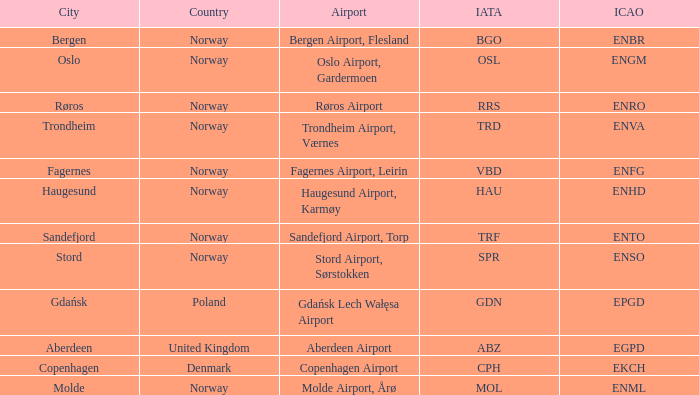Can you parse all the data within this table? {'header': ['City', 'Country', 'Airport', 'IATA', 'ICAO'], 'rows': [['Bergen', 'Norway', 'Bergen Airport, Flesland', 'BGO', 'ENBR'], ['Oslo', 'Norway', 'Oslo Airport, Gardermoen', 'OSL', 'ENGM'], ['Røros', 'Norway', 'Røros Airport', 'RRS', 'ENRO'], ['Trondheim', 'Norway', 'Trondheim Airport, Værnes', 'TRD', 'ENVA'], ['Fagernes', 'Norway', 'Fagernes Airport, Leirin', 'VBD', 'ENFG'], ['Haugesund', 'Norway', 'Haugesund Airport, Karmøy', 'HAU', 'ENHD'], ['Sandefjord', 'Norway', 'Sandefjord Airport, Torp', 'TRF', 'ENTO'], ['Stord', 'Norway', 'Stord Airport, Sørstokken', 'SPR', 'ENSO'], ['Gdańsk', 'Poland', 'Gdańsk Lech Wałęsa Airport', 'GDN', 'EPGD'], ['Aberdeen', 'United Kingdom', 'Aberdeen Airport', 'ABZ', 'EGPD'], ['Copenhagen', 'Denmark', 'Copenhagen Airport', 'CPH', 'EKCH'], ['Molde', 'Norway', 'Molde Airport, Årø', 'MOL', 'ENML']]} What is th IATA for Norway with an ICAO of ENTO? TRF. 